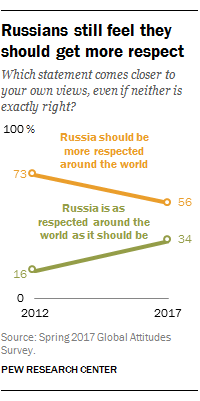Highlight a few significant elements in this photo. The product of the largest value of the orange graph and the rightmost value of the green graph is 2482. In 2017, the value of green bars was 34. 